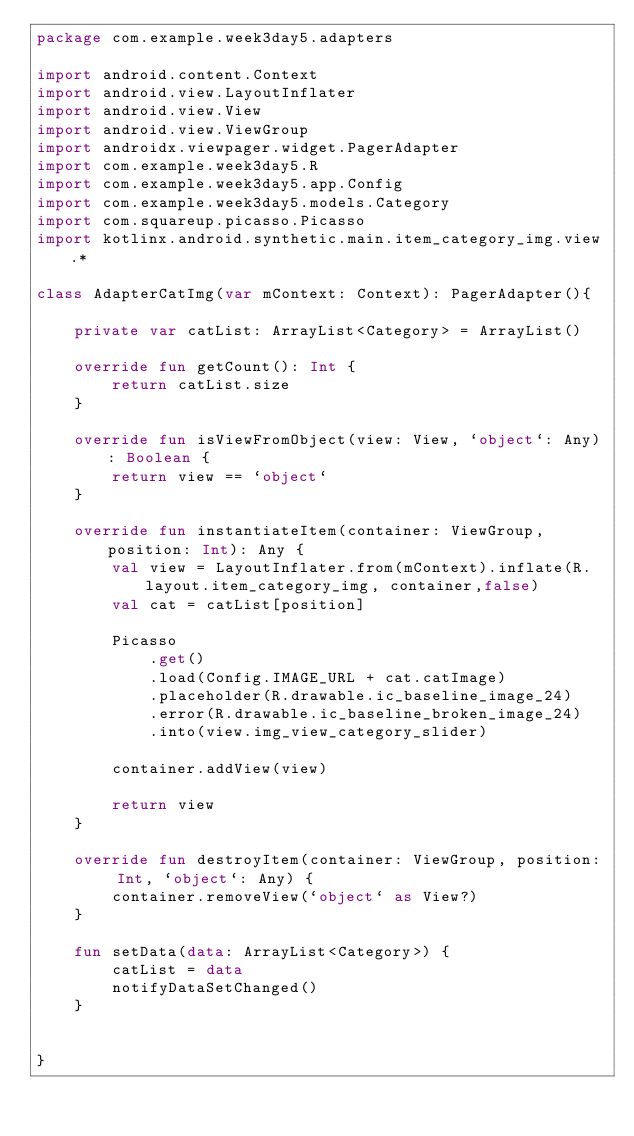Convert code to text. <code><loc_0><loc_0><loc_500><loc_500><_Kotlin_>package com.example.week3day5.adapters

import android.content.Context
import android.view.LayoutInflater
import android.view.View
import android.view.ViewGroup
import androidx.viewpager.widget.PagerAdapter
import com.example.week3day5.R
import com.example.week3day5.app.Config
import com.example.week3day5.models.Category
import com.squareup.picasso.Picasso
import kotlinx.android.synthetic.main.item_category_img.view.*

class AdapterCatImg(var mContext: Context): PagerAdapter(){

    private var catList: ArrayList<Category> = ArrayList()

    override fun getCount(): Int {
        return catList.size
    }

    override fun isViewFromObject(view: View, `object`: Any): Boolean {
        return view == `object`
    }

    override fun instantiateItem(container: ViewGroup, position: Int): Any {
        val view = LayoutInflater.from(mContext).inflate(R.layout.item_category_img, container,false)
        val cat = catList[position]

        Picasso
            .get()
            .load(Config.IMAGE_URL + cat.catImage)
            .placeholder(R.drawable.ic_baseline_image_24)
            .error(R.drawable.ic_baseline_broken_image_24)
            .into(view.img_view_category_slider)

        container.addView(view)

        return view
    }

    override fun destroyItem(container: ViewGroup, position: Int, `object`: Any) {
        container.removeView(`object` as View?)
    }

    fun setData(data: ArrayList<Category>) {
        catList = data
        notifyDataSetChanged()
    }


}</code> 